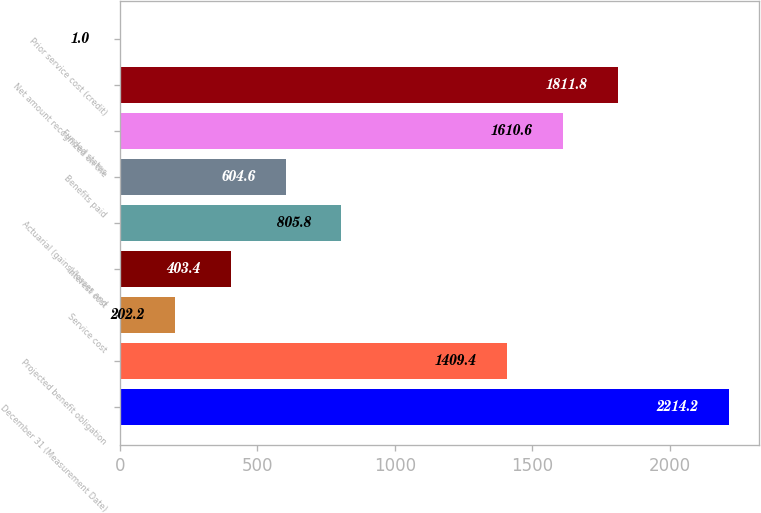Convert chart. <chart><loc_0><loc_0><loc_500><loc_500><bar_chart><fcel>December 31 (Measurement Date)<fcel>Projected benefit obligation<fcel>Service cost<fcel>Interest cost<fcel>Actuarial (gains)/losses and<fcel>Benefits paid<fcel>Funded status<fcel>Net amount recognized on the<fcel>Prior service cost (credit)<nl><fcel>2214.2<fcel>1409.4<fcel>202.2<fcel>403.4<fcel>805.8<fcel>604.6<fcel>1610.6<fcel>1811.8<fcel>1<nl></chart> 